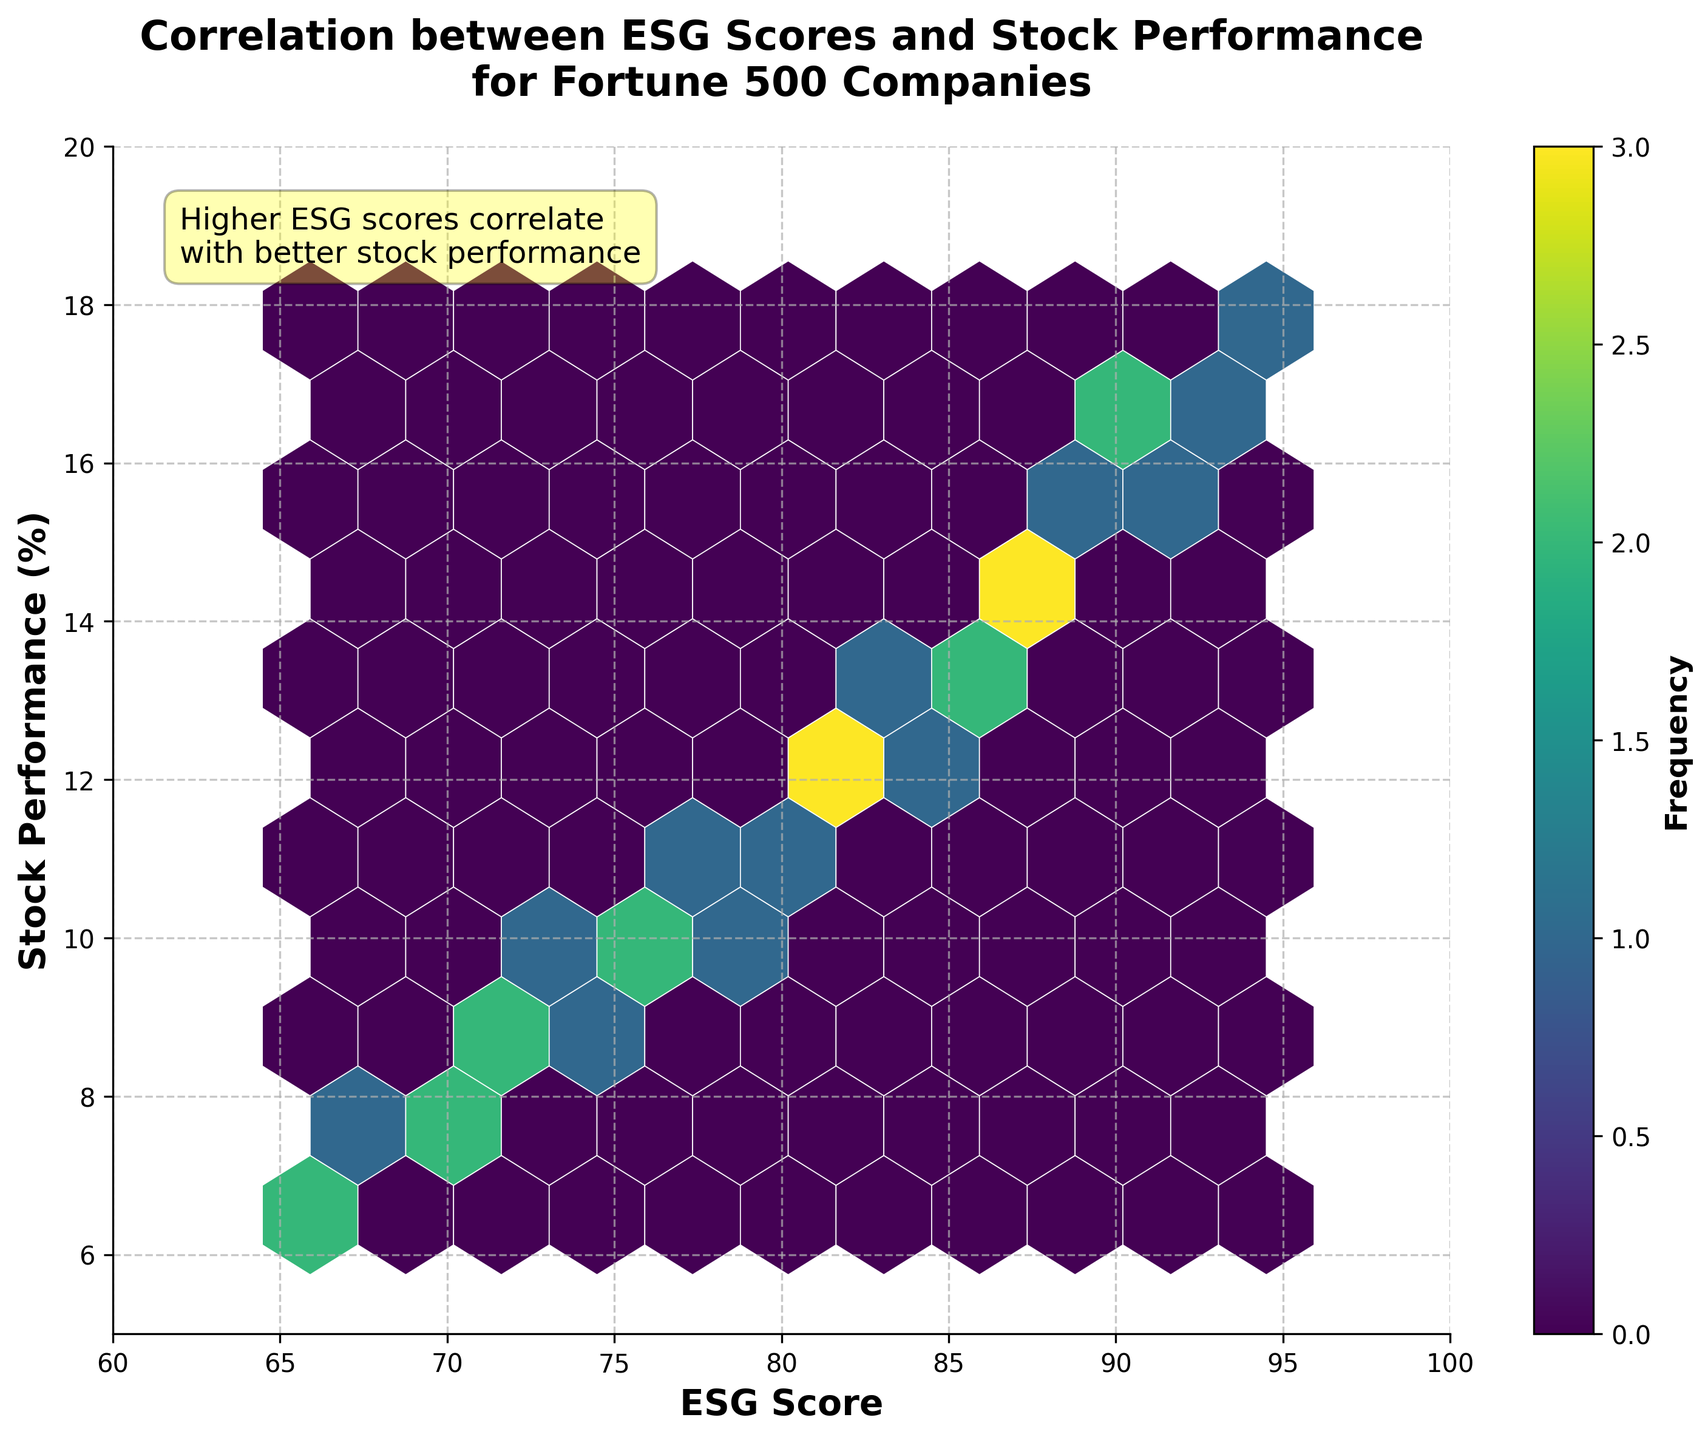What does the title of the hexbin plot indicate? The title of the hexbin plot states "Correlation between ESG Scores and Stock Performance for Fortune 500 Companies," indicating that the plot shows the relationship between ESG scores and stock performance for these companies.
Answer: The title shows the relationship between ESG scores and stock performance for Fortune 500 companies What do the x-axis and y-axis represent? The x-axis is labeled "ESG Score," and the y-axis is labeled "Stock Performance (%)," meaning the x-axis represents the ESG scores, and the y-axis represents the stock performance percentage.
Answer: The x-axis represents ESG scores, and the y-axis represents stock performance percentage What does the color bar on the right side of the plot represent? The color bar on the right side of the plot is labeled "Frequency," and its color gradient indicates the number of data points or frequency within each hexagonal bin. "Viridis" is the color map used, so different shades represent different frequencies.
Answer: The color bar indicates the frequency of data points within each hexagonal bin How would you describe the general trend shown in the plot? The plot generally shows a positive correlation between ESG scores and stock performance, indicated by denser hexagonal bins towards the upper right corner of the plot.
Answer: There is a positive correlation between ESG scores and stock performance Which range of ESG scores has the highest frequency of hexagonal bins, and what is the corresponding stock performance range? The densest hexagonal bins are generally in the ESG score range between 85 and 95, and the corresponding stock performance for these bins is between 12 and 17%.
Answer: ESG score range 85-95 and stock performance 12-17% How do stock performances compare for companies with ESG scores above 90 to those with ESG scores below 70? Hexagonal bins for ESG scores above 90 are denser and higher on the y-axis, indicating better stock performance compared to the bins for ESG scores below 70, which are sparser and lower on the y-axis.
Answer: Companies with ESG scores above 90 have better stock performance than those with scores below 70 